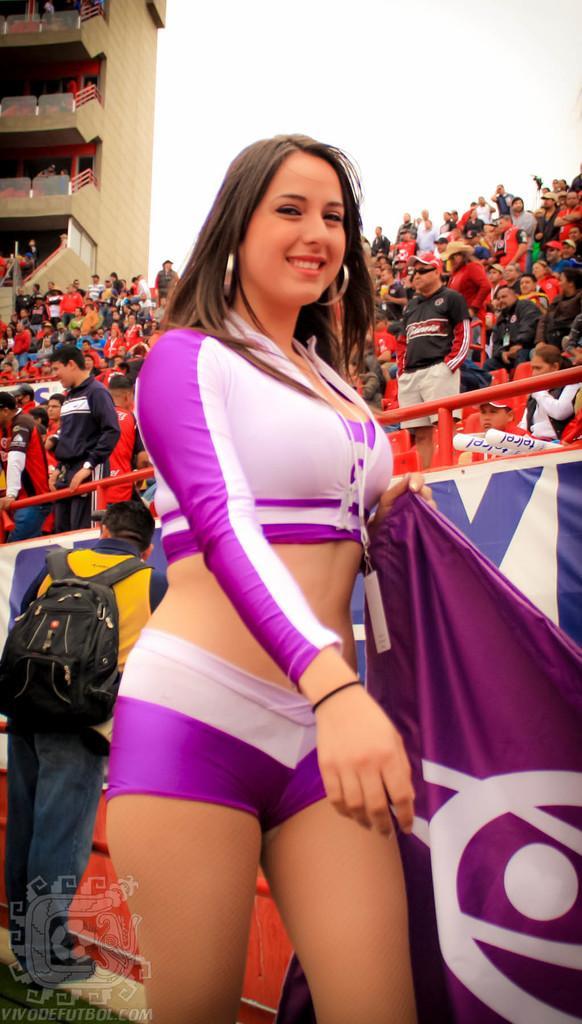Please provide a concise description of this image. In the center of the image there is a woman standing and holding a flag. In the background there is a fencing, crowd, building and sky. 